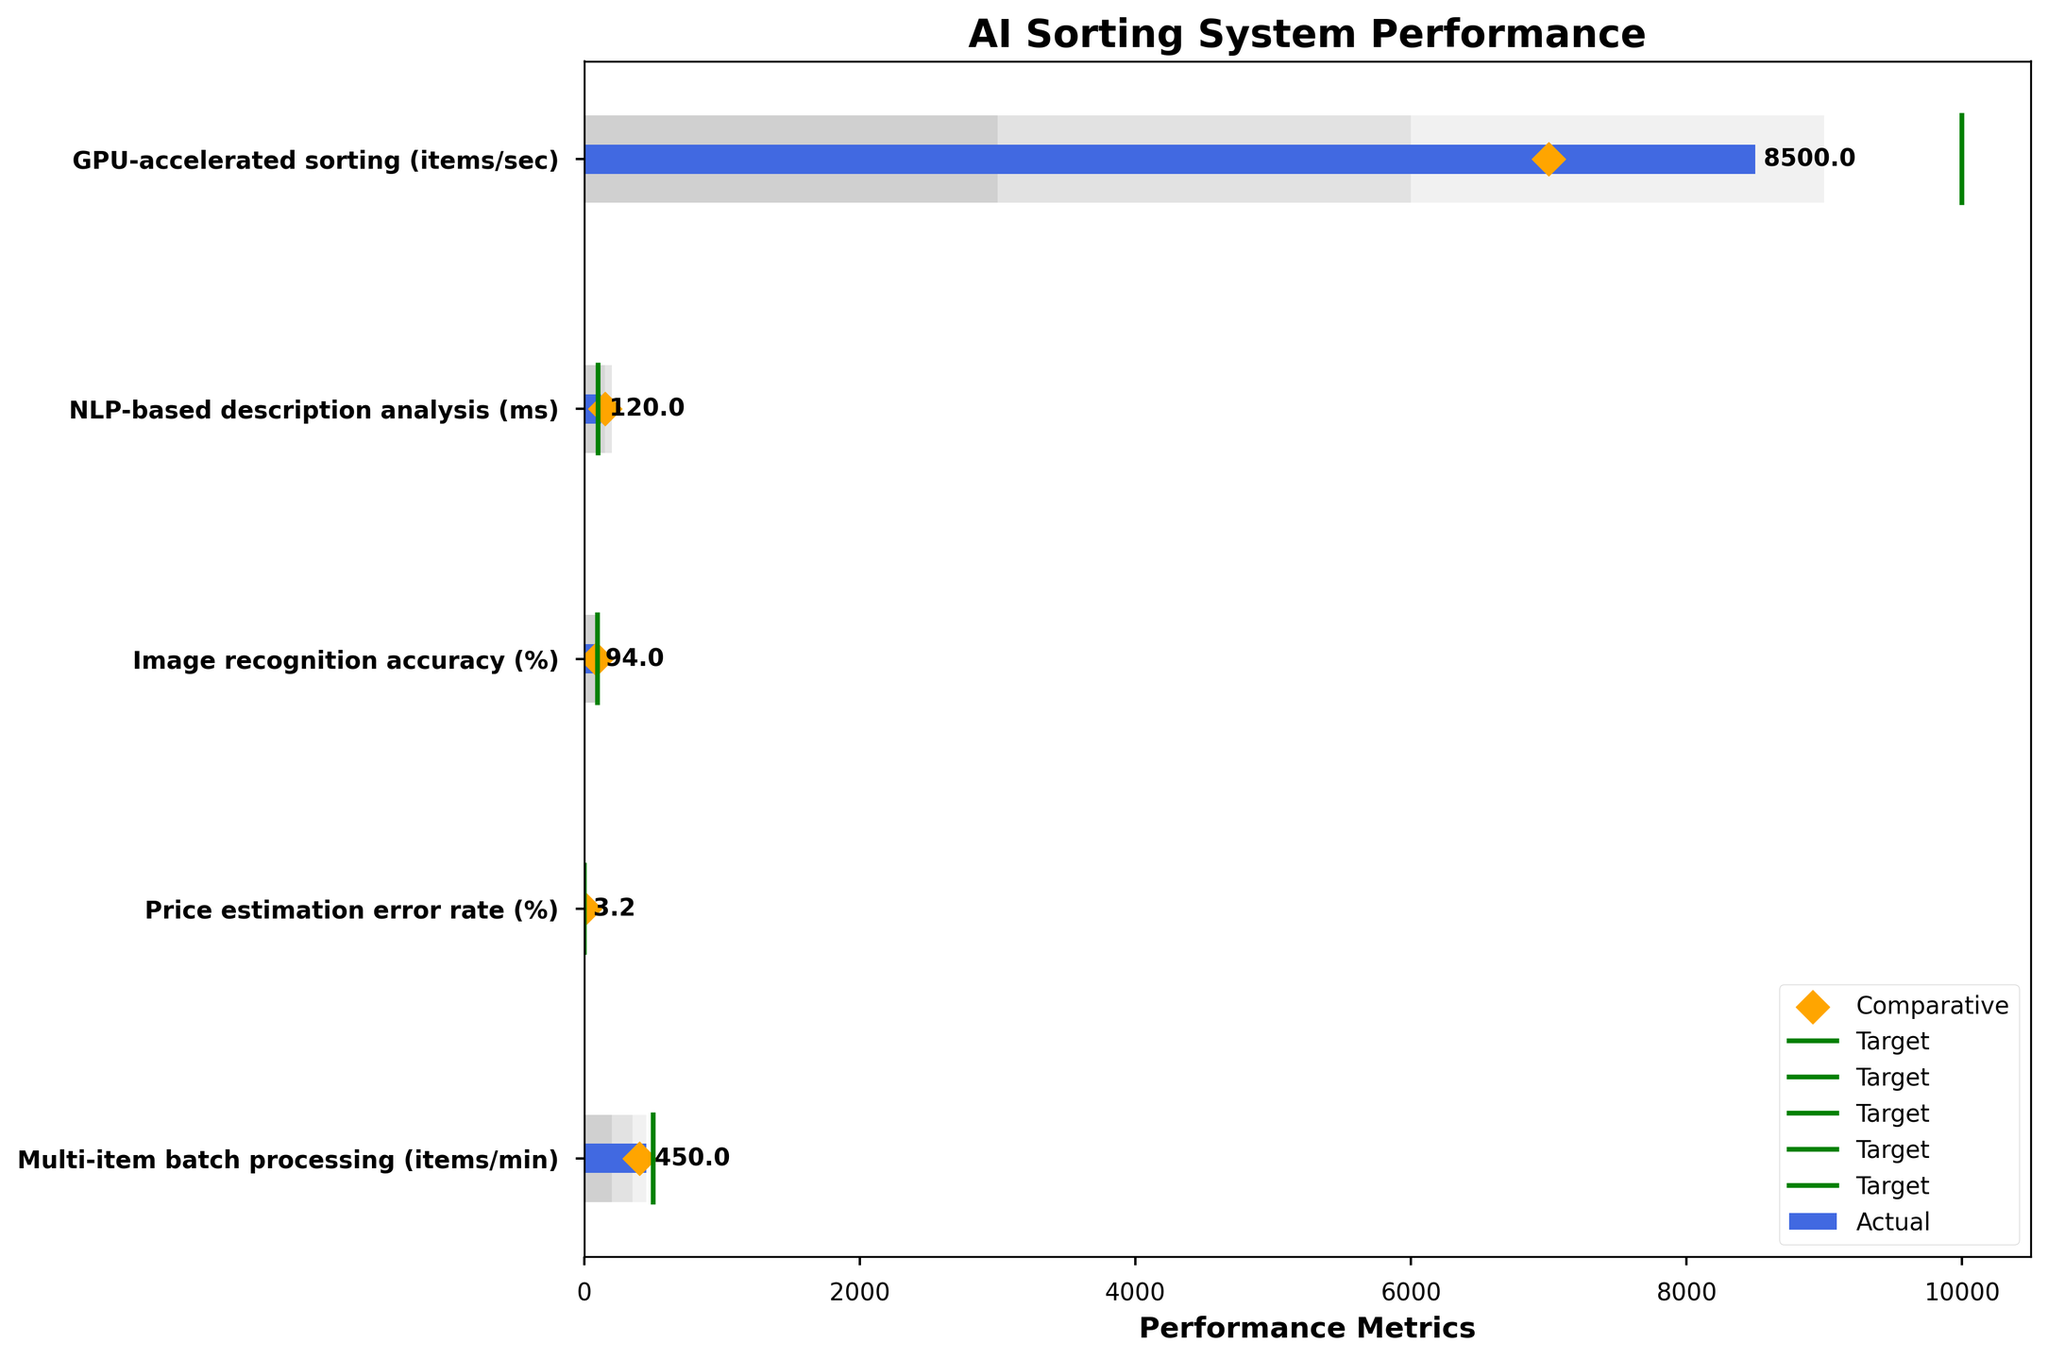What is the actual processing speed of the GPU-accelerated sorting system, and how does it compare to the industry benchmark? The actual processing speed is given by the blue bar for "GPU-accelerated sorting (items/sec)", and the industry benchmark is represented by the orange diamond. The actual value is 8500 items/sec, and the benchmark is 7000 items/sec. The calculation shows that the actual processing speed is higher than the benchmark by 8500 - 7000 = 1500 items/sec.
Answer: 8500 items/sec is 1500 items/sec higher What is the target processing time for the NLP-based description analysis, and what is the actual performance compared to this target? The target value is indicated by the green line, and for "NLP-based description analysis (ms)", it is 100 ms. The actual performance is shown by the blue bar and has a value of 120 ms. The actual performance is higher than the target by 120 - 100 = 20 ms.
Answer: 100 ms, 20 ms higher How does the multi-item batch processing speed compare to its target and comparative values? For "Multi-item batch processing (items/min)", the target value (green line) is 500 items/min, the actual value (blue bar) is 450 items/min, and the comparative value (orange diamond) is 400 items/min. The actual speed is 50 items/min below the target and 50 items/min above the comparative value.
Answer: 50 items/min below target, 50 items/min above comparative Which category's actual performance is the closest to its target value? To find the category closest to its target, calculate the absolute difference between actual and target for each category. Closest means the smallest difference. The differences are: GPU-accelerated sorting (1500), NLP-based description analysis (20), Image recognition accuracy (1), Price estimation error rate (0.7), Multi-item batch processing (50). The smallest difference is for "Image recognition accuracy (%)" with a difference of 1%.
Answer: Image recognition accuracy (%) What is the range spread for the GPU-accelerated sorting system, and in which range does the actual performance fall? For "GPU-accelerated sorting (items/sec)", the ranges are 3000 (Range1), 6000 (Range2), 9000 (Range3). The actual performance (8500 items/sec) falls into Range2 (dark grey) and Range3 combined (with Range3, light grey, being the largest range up to 9000). The actual is within the range of 6000 to 9000 items/sec.
Answer: 3000, 6000, 9000; falls within Range2 and Range3 Which category has the lowest comparative value, and is this category's actual performance higher or lower than the comparative value? Scan the comparative values (orange diamonds) to find the lowest one. The lowest comparative value is for "Price estimation error rate (%)" at 5%. The actual performance for this category (3.2%) is lower than the comparative value.
Answer: Price estimation error rate (%); lower Which categories have an actual performance exceeding their target? Compare the blue bar (actual) values to the green line (target) values to see which are greater: GPU-accelerated sorting (8500 > 10000) not exceeding, NLP-based description analysis (120 > 100) not exceeding, Image recognition accuracy (94 < 95) not exceeding, Price estimation error rate (3.2 > 2.5) not exceeding, Multi-item batch processing (450 < 500) not exceeding. None of the categories exceed their target.
Answer: None What is the performance improvement (in ms) of the actual NLP-based description analysis compared to the comparative value? For "NLP-based description analysis (ms)", the comparative value is 150 ms and the actual value is 120 ms. The improvement is calculated as 150 - 120 = 30 ms.
Answer: 30 ms improvement What is the difference between the actual and the target values for the price estimation error rate? The actual value for "Price estimation error rate (%)" is 3.2%, and the target value is 2.5%. The difference is 3.2 - 2.5 = 0.7%.
Answer: 0.7% How close is the actual value of image recognition accuracy to achieving the high target range? The high target range for "Image recognition accuracy (%)" can be understood as exceeding the upper limit of its ranges (90%). The actual value being 94% means it is already within the high target range.
Answer: Within high target range (94%) 